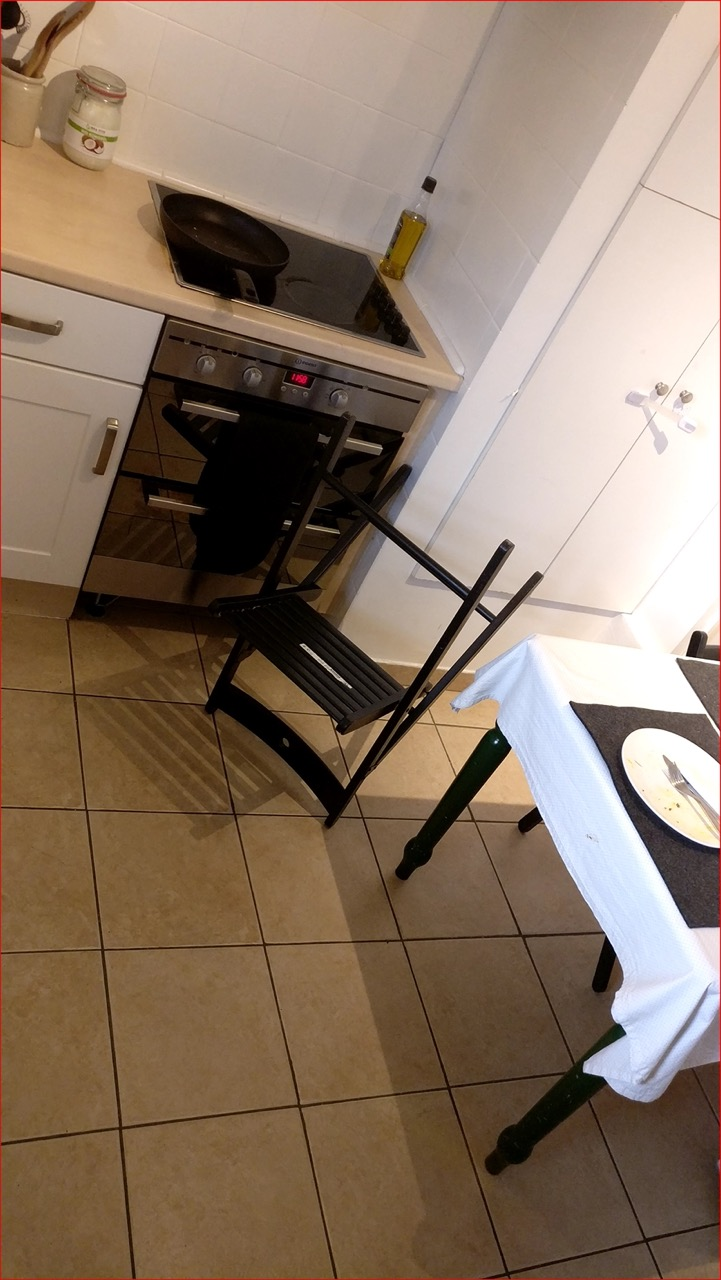How many chairs are there in the image? There is one visible chair in the image, specifically positioned near the table. It appears to be a dining chair, and its placement suggests it might be part of a dining set, often used in a kitchen or dining area for meals. 